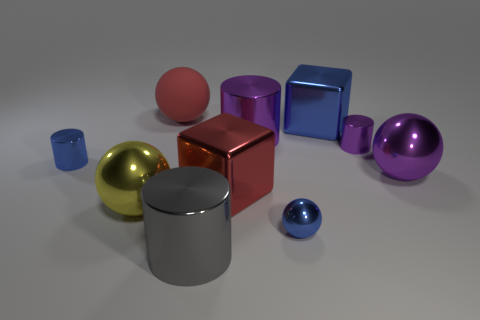How many objects are either large gray rubber blocks or balls that are in front of the large yellow metallic ball?
Offer a very short reply. 1. Are there fewer small purple metal spheres than gray things?
Provide a short and direct response. Yes. The big metal sphere that is on the right side of the tiny cylinder behind the small blue shiny cylinder is what color?
Give a very brief answer. Purple. What is the material of the small blue thing that is the same shape as the big gray object?
Your response must be concise. Metal. What number of metallic objects are either yellow objects or small blue objects?
Make the answer very short. 3. Is the red object that is on the left side of the big red metallic block made of the same material as the purple cylinder to the left of the large blue cube?
Offer a very short reply. No. Are any red objects visible?
Give a very brief answer. Yes. There is a large purple shiny object left of the tiny metallic sphere; is its shape the same as the small metallic object that is in front of the large red metal block?
Make the answer very short. No. Is there a big green object that has the same material as the small purple object?
Provide a short and direct response. No. Is the block that is in front of the tiny purple thing made of the same material as the yellow thing?
Keep it short and to the point. Yes. 